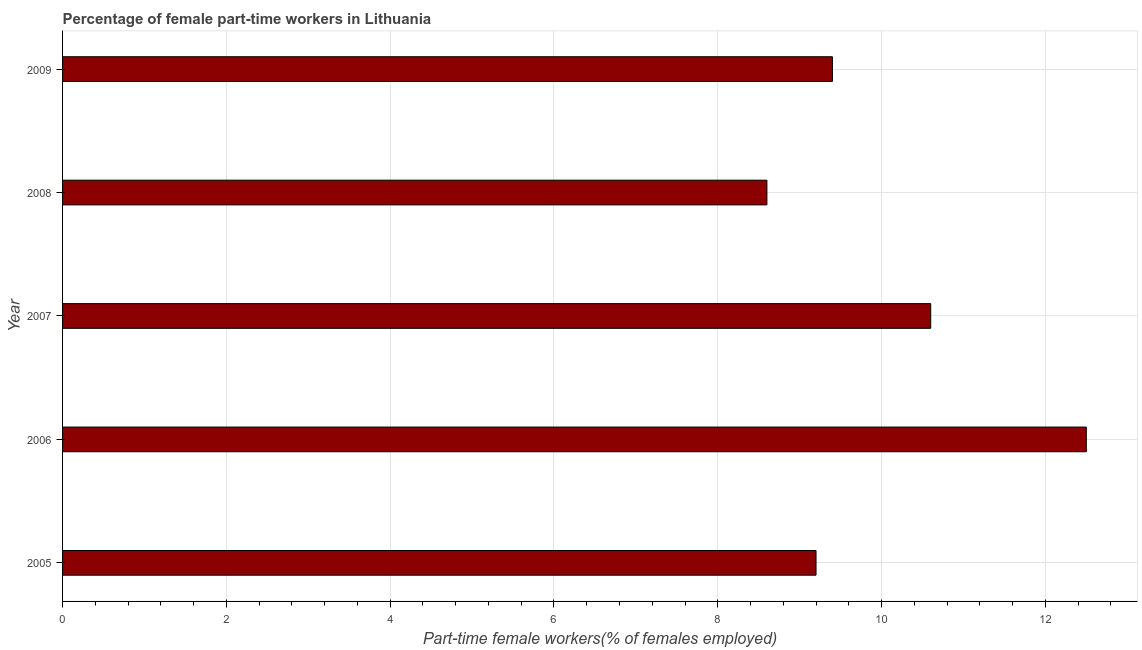Does the graph contain any zero values?
Your answer should be compact. No. Does the graph contain grids?
Your answer should be compact. Yes. What is the title of the graph?
Offer a very short reply. Percentage of female part-time workers in Lithuania. What is the label or title of the X-axis?
Make the answer very short. Part-time female workers(% of females employed). What is the label or title of the Y-axis?
Provide a short and direct response. Year. What is the percentage of part-time female workers in 2008?
Ensure brevity in your answer.  8.6. Across all years, what is the minimum percentage of part-time female workers?
Provide a short and direct response. 8.6. In which year was the percentage of part-time female workers maximum?
Provide a short and direct response. 2006. In which year was the percentage of part-time female workers minimum?
Your answer should be compact. 2008. What is the sum of the percentage of part-time female workers?
Keep it short and to the point. 50.3. What is the difference between the percentage of part-time female workers in 2006 and 2007?
Make the answer very short. 1.9. What is the average percentage of part-time female workers per year?
Make the answer very short. 10.06. What is the median percentage of part-time female workers?
Provide a short and direct response. 9.4. What is the ratio of the percentage of part-time female workers in 2007 to that in 2009?
Provide a short and direct response. 1.13. Is the difference between the percentage of part-time female workers in 2006 and 2007 greater than the difference between any two years?
Give a very brief answer. No. What is the difference between the highest and the second highest percentage of part-time female workers?
Make the answer very short. 1.9. In how many years, is the percentage of part-time female workers greater than the average percentage of part-time female workers taken over all years?
Offer a terse response. 2. How many bars are there?
Provide a short and direct response. 5. What is the difference between two consecutive major ticks on the X-axis?
Provide a short and direct response. 2. Are the values on the major ticks of X-axis written in scientific E-notation?
Give a very brief answer. No. What is the Part-time female workers(% of females employed) of 2005?
Provide a short and direct response. 9.2. What is the Part-time female workers(% of females employed) of 2007?
Offer a very short reply. 10.6. What is the Part-time female workers(% of females employed) in 2008?
Your answer should be very brief. 8.6. What is the Part-time female workers(% of females employed) in 2009?
Provide a succinct answer. 9.4. What is the difference between the Part-time female workers(% of females employed) in 2005 and 2007?
Your answer should be very brief. -1.4. What is the difference between the Part-time female workers(% of females employed) in 2005 and 2009?
Provide a short and direct response. -0.2. What is the difference between the Part-time female workers(% of females employed) in 2006 and 2007?
Provide a succinct answer. 1.9. What is the difference between the Part-time female workers(% of females employed) in 2006 and 2008?
Your response must be concise. 3.9. What is the difference between the Part-time female workers(% of females employed) in 2006 and 2009?
Your answer should be very brief. 3.1. What is the difference between the Part-time female workers(% of females employed) in 2007 and 2009?
Your answer should be very brief. 1.2. What is the ratio of the Part-time female workers(% of females employed) in 2005 to that in 2006?
Make the answer very short. 0.74. What is the ratio of the Part-time female workers(% of females employed) in 2005 to that in 2007?
Your answer should be compact. 0.87. What is the ratio of the Part-time female workers(% of females employed) in 2005 to that in 2008?
Give a very brief answer. 1.07. What is the ratio of the Part-time female workers(% of females employed) in 2006 to that in 2007?
Your answer should be compact. 1.18. What is the ratio of the Part-time female workers(% of females employed) in 2006 to that in 2008?
Offer a terse response. 1.45. What is the ratio of the Part-time female workers(% of females employed) in 2006 to that in 2009?
Ensure brevity in your answer.  1.33. What is the ratio of the Part-time female workers(% of females employed) in 2007 to that in 2008?
Make the answer very short. 1.23. What is the ratio of the Part-time female workers(% of females employed) in 2007 to that in 2009?
Make the answer very short. 1.13. What is the ratio of the Part-time female workers(% of females employed) in 2008 to that in 2009?
Give a very brief answer. 0.92. 